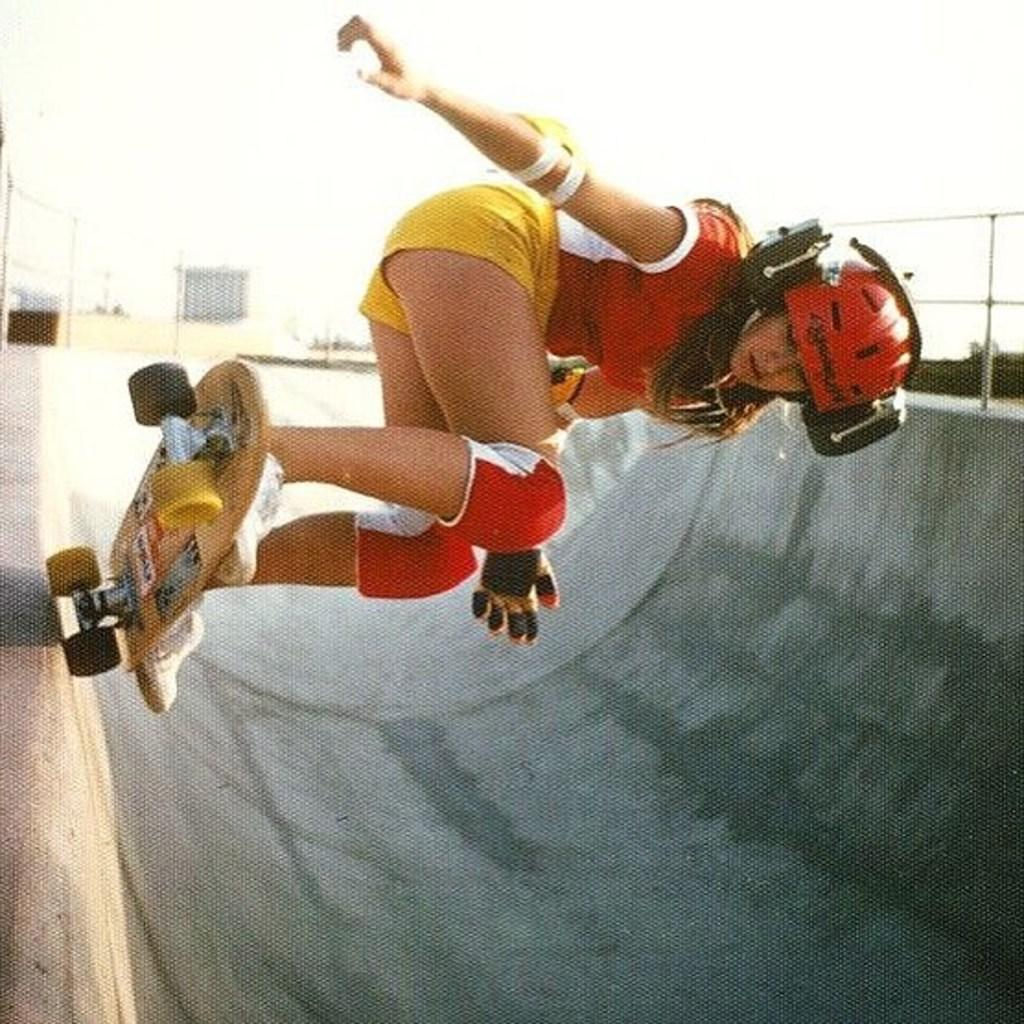Who is the main subject in the image? There is a woman in the image. What is the woman doing in the image? The woman is skating on a skateboard. What safety gear is the woman wearing? The woman is wearing a helmet and knee pads. What type of footwear is the woman wearing? The woman is wearing shoes. What can be seen in the background of the image? There is sky and a building visible in the background of the image. How many trees can be seen in the image? There are no trees visible in the image; it features a woman skating on a skateboard with a background of sky and a building. What type of spiders are crawling on the woman's skateboard in the image? There are no spiders present in the image. 